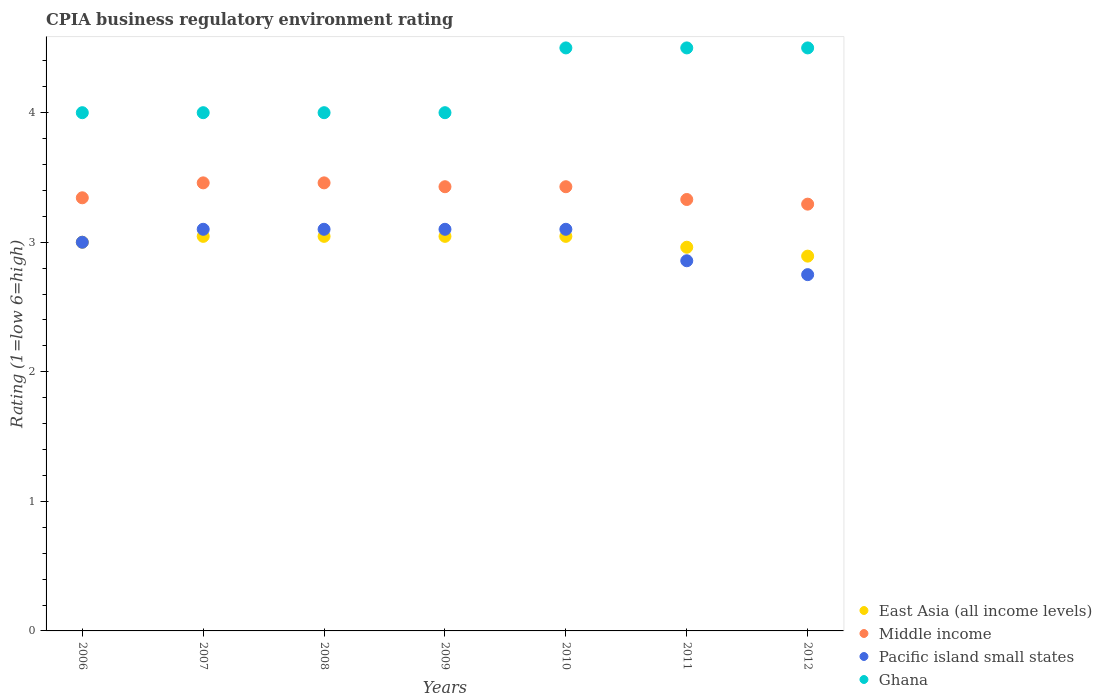How many different coloured dotlines are there?
Ensure brevity in your answer.  4. What is the CPIA rating in Middle income in 2009?
Provide a succinct answer. 3.43. Across all years, what is the maximum CPIA rating in Middle income?
Your answer should be very brief. 3.46. Across all years, what is the minimum CPIA rating in Pacific island small states?
Your response must be concise. 2.75. In which year was the CPIA rating in Ghana maximum?
Offer a very short reply. 2010. What is the total CPIA rating in East Asia (all income levels) in the graph?
Offer a terse response. 21.04. What is the difference between the CPIA rating in East Asia (all income levels) in 2008 and that in 2011?
Make the answer very short. 0.08. What is the difference between the CPIA rating in Ghana in 2006 and the CPIA rating in East Asia (all income levels) in 2007?
Keep it short and to the point. 0.95. What is the average CPIA rating in East Asia (all income levels) per year?
Ensure brevity in your answer.  3.01. In the year 2008, what is the difference between the CPIA rating in Ghana and CPIA rating in Pacific island small states?
Give a very brief answer. 0.9. What is the ratio of the CPIA rating in East Asia (all income levels) in 2007 to that in 2011?
Your answer should be compact. 1.03. Is the CPIA rating in Ghana in 2010 less than that in 2012?
Provide a short and direct response. No. What is the difference between the highest and the second highest CPIA rating in Ghana?
Provide a succinct answer. 0. What is the difference between the highest and the lowest CPIA rating in Ghana?
Keep it short and to the point. 0.5. Is it the case that in every year, the sum of the CPIA rating in East Asia (all income levels) and CPIA rating in Middle income  is greater than the sum of CPIA rating in Ghana and CPIA rating in Pacific island small states?
Your answer should be very brief. No. Is it the case that in every year, the sum of the CPIA rating in Ghana and CPIA rating in Middle income  is greater than the CPIA rating in East Asia (all income levels)?
Your response must be concise. Yes. Does the CPIA rating in Pacific island small states monotonically increase over the years?
Ensure brevity in your answer.  No. Is the CPIA rating in Ghana strictly greater than the CPIA rating in Pacific island small states over the years?
Offer a very short reply. Yes. Is the CPIA rating in East Asia (all income levels) strictly less than the CPIA rating in Ghana over the years?
Ensure brevity in your answer.  Yes. Does the graph contain any zero values?
Provide a short and direct response. No. Does the graph contain grids?
Your answer should be very brief. No. Where does the legend appear in the graph?
Your answer should be very brief. Bottom right. How many legend labels are there?
Provide a short and direct response. 4. What is the title of the graph?
Keep it short and to the point. CPIA business regulatory environment rating. What is the label or title of the X-axis?
Your response must be concise. Years. What is the Rating (1=low 6=high) in Middle income in 2006?
Your answer should be very brief. 3.34. What is the Rating (1=low 6=high) of Ghana in 2006?
Provide a succinct answer. 4. What is the Rating (1=low 6=high) in East Asia (all income levels) in 2007?
Keep it short and to the point. 3.05. What is the Rating (1=low 6=high) in Middle income in 2007?
Give a very brief answer. 3.46. What is the Rating (1=low 6=high) in Pacific island small states in 2007?
Offer a very short reply. 3.1. What is the Rating (1=low 6=high) in Ghana in 2007?
Give a very brief answer. 4. What is the Rating (1=low 6=high) in East Asia (all income levels) in 2008?
Offer a very short reply. 3.05. What is the Rating (1=low 6=high) in Middle income in 2008?
Provide a succinct answer. 3.46. What is the Rating (1=low 6=high) of Ghana in 2008?
Your answer should be very brief. 4. What is the Rating (1=low 6=high) of East Asia (all income levels) in 2009?
Your response must be concise. 3.05. What is the Rating (1=low 6=high) in Middle income in 2009?
Give a very brief answer. 3.43. What is the Rating (1=low 6=high) in Pacific island small states in 2009?
Make the answer very short. 3.1. What is the Rating (1=low 6=high) in East Asia (all income levels) in 2010?
Provide a succinct answer. 3.05. What is the Rating (1=low 6=high) in Middle income in 2010?
Your answer should be very brief. 3.43. What is the Rating (1=low 6=high) of Ghana in 2010?
Your answer should be very brief. 4.5. What is the Rating (1=low 6=high) of East Asia (all income levels) in 2011?
Provide a short and direct response. 2.96. What is the Rating (1=low 6=high) of Middle income in 2011?
Your answer should be very brief. 3.33. What is the Rating (1=low 6=high) of Pacific island small states in 2011?
Give a very brief answer. 2.86. What is the Rating (1=low 6=high) in Ghana in 2011?
Your answer should be very brief. 4.5. What is the Rating (1=low 6=high) in East Asia (all income levels) in 2012?
Ensure brevity in your answer.  2.89. What is the Rating (1=low 6=high) in Middle income in 2012?
Keep it short and to the point. 3.29. What is the Rating (1=low 6=high) in Pacific island small states in 2012?
Offer a terse response. 2.75. Across all years, what is the maximum Rating (1=low 6=high) in East Asia (all income levels)?
Your answer should be compact. 3.05. Across all years, what is the maximum Rating (1=low 6=high) in Middle income?
Provide a succinct answer. 3.46. Across all years, what is the minimum Rating (1=low 6=high) in East Asia (all income levels)?
Your answer should be very brief. 2.89. Across all years, what is the minimum Rating (1=low 6=high) in Middle income?
Offer a terse response. 3.29. Across all years, what is the minimum Rating (1=low 6=high) of Pacific island small states?
Provide a short and direct response. 2.75. What is the total Rating (1=low 6=high) in East Asia (all income levels) in the graph?
Your answer should be compact. 21.04. What is the total Rating (1=low 6=high) of Middle income in the graph?
Keep it short and to the point. 23.74. What is the total Rating (1=low 6=high) of Pacific island small states in the graph?
Offer a very short reply. 21.01. What is the total Rating (1=low 6=high) in Ghana in the graph?
Provide a short and direct response. 29.5. What is the difference between the Rating (1=low 6=high) in East Asia (all income levels) in 2006 and that in 2007?
Provide a short and direct response. -0.05. What is the difference between the Rating (1=low 6=high) of Middle income in 2006 and that in 2007?
Ensure brevity in your answer.  -0.12. What is the difference between the Rating (1=low 6=high) of East Asia (all income levels) in 2006 and that in 2008?
Offer a very short reply. -0.05. What is the difference between the Rating (1=low 6=high) in Middle income in 2006 and that in 2008?
Make the answer very short. -0.12. What is the difference between the Rating (1=low 6=high) in East Asia (all income levels) in 2006 and that in 2009?
Offer a very short reply. -0.05. What is the difference between the Rating (1=low 6=high) of Middle income in 2006 and that in 2009?
Your answer should be very brief. -0.09. What is the difference between the Rating (1=low 6=high) in East Asia (all income levels) in 2006 and that in 2010?
Your answer should be compact. -0.05. What is the difference between the Rating (1=low 6=high) in Middle income in 2006 and that in 2010?
Your answer should be very brief. -0.09. What is the difference between the Rating (1=low 6=high) in Ghana in 2006 and that in 2010?
Give a very brief answer. -0.5. What is the difference between the Rating (1=low 6=high) of East Asia (all income levels) in 2006 and that in 2011?
Make the answer very short. 0.04. What is the difference between the Rating (1=low 6=high) in Middle income in 2006 and that in 2011?
Provide a short and direct response. 0.01. What is the difference between the Rating (1=low 6=high) of Pacific island small states in 2006 and that in 2011?
Provide a succinct answer. 0.14. What is the difference between the Rating (1=low 6=high) in East Asia (all income levels) in 2006 and that in 2012?
Your answer should be very brief. 0.11. What is the difference between the Rating (1=low 6=high) in Middle income in 2006 and that in 2012?
Your answer should be compact. 0.05. What is the difference between the Rating (1=low 6=high) of Ghana in 2006 and that in 2012?
Give a very brief answer. -0.5. What is the difference between the Rating (1=low 6=high) of Middle income in 2007 and that in 2008?
Offer a very short reply. 0. What is the difference between the Rating (1=low 6=high) in Ghana in 2007 and that in 2008?
Your response must be concise. 0. What is the difference between the Rating (1=low 6=high) in East Asia (all income levels) in 2007 and that in 2009?
Provide a succinct answer. 0. What is the difference between the Rating (1=low 6=high) in Middle income in 2007 and that in 2009?
Provide a short and direct response. 0.03. What is the difference between the Rating (1=low 6=high) of Pacific island small states in 2007 and that in 2009?
Ensure brevity in your answer.  0. What is the difference between the Rating (1=low 6=high) of Ghana in 2007 and that in 2009?
Your answer should be very brief. 0. What is the difference between the Rating (1=low 6=high) in Middle income in 2007 and that in 2010?
Give a very brief answer. 0.03. What is the difference between the Rating (1=low 6=high) of Ghana in 2007 and that in 2010?
Your response must be concise. -0.5. What is the difference between the Rating (1=low 6=high) of East Asia (all income levels) in 2007 and that in 2011?
Make the answer very short. 0.08. What is the difference between the Rating (1=low 6=high) in Middle income in 2007 and that in 2011?
Offer a very short reply. 0.13. What is the difference between the Rating (1=low 6=high) of Pacific island small states in 2007 and that in 2011?
Keep it short and to the point. 0.24. What is the difference between the Rating (1=low 6=high) of East Asia (all income levels) in 2007 and that in 2012?
Keep it short and to the point. 0.15. What is the difference between the Rating (1=low 6=high) in Middle income in 2007 and that in 2012?
Your response must be concise. 0.16. What is the difference between the Rating (1=low 6=high) in Ghana in 2007 and that in 2012?
Ensure brevity in your answer.  -0.5. What is the difference between the Rating (1=low 6=high) of Middle income in 2008 and that in 2009?
Ensure brevity in your answer.  0.03. What is the difference between the Rating (1=low 6=high) of Pacific island small states in 2008 and that in 2009?
Your response must be concise. 0. What is the difference between the Rating (1=low 6=high) in Ghana in 2008 and that in 2009?
Give a very brief answer. 0. What is the difference between the Rating (1=low 6=high) in Middle income in 2008 and that in 2010?
Make the answer very short. 0.03. What is the difference between the Rating (1=low 6=high) in Pacific island small states in 2008 and that in 2010?
Ensure brevity in your answer.  0. What is the difference between the Rating (1=low 6=high) of East Asia (all income levels) in 2008 and that in 2011?
Your response must be concise. 0.08. What is the difference between the Rating (1=low 6=high) of Middle income in 2008 and that in 2011?
Keep it short and to the point. 0.13. What is the difference between the Rating (1=low 6=high) in Pacific island small states in 2008 and that in 2011?
Offer a terse response. 0.24. What is the difference between the Rating (1=low 6=high) in East Asia (all income levels) in 2008 and that in 2012?
Ensure brevity in your answer.  0.15. What is the difference between the Rating (1=low 6=high) in Middle income in 2008 and that in 2012?
Ensure brevity in your answer.  0.16. What is the difference between the Rating (1=low 6=high) in East Asia (all income levels) in 2009 and that in 2010?
Your response must be concise. 0. What is the difference between the Rating (1=low 6=high) in Ghana in 2009 and that in 2010?
Keep it short and to the point. -0.5. What is the difference between the Rating (1=low 6=high) in East Asia (all income levels) in 2009 and that in 2011?
Provide a short and direct response. 0.08. What is the difference between the Rating (1=low 6=high) in Middle income in 2009 and that in 2011?
Your answer should be compact. 0.1. What is the difference between the Rating (1=low 6=high) of Pacific island small states in 2009 and that in 2011?
Provide a succinct answer. 0.24. What is the difference between the Rating (1=low 6=high) of East Asia (all income levels) in 2009 and that in 2012?
Keep it short and to the point. 0.15. What is the difference between the Rating (1=low 6=high) of Middle income in 2009 and that in 2012?
Your response must be concise. 0.13. What is the difference between the Rating (1=low 6=high) in East Asia (all income levels) in 2010 and that in 2011?
Make the answer very short. 0.08. What is the difference between the Rating (1=low 6=high) in Middle income in 2010 and that in 2011?
Your answer should be very brief. 0.1. What is the difference between the Rating (1=low 6=high) in Pacific island small states in 2010 and that in 2011?
Provide a short and direct response. 0.24. What is the difference between the Rating (1=low 6=high) of East Asia (all income levels) in 2010 and that in 2012?
Provide a short and direct response. 0.15. What is the difference between the Rating (1=low 6=high) in Middle income in 2010 and that in 2012?
Offer a very short reply. 0.13. What is the difference between the Rating (1=low 6=high) in Ghana in 2010 and that in 2012?
Provide a succinct answer. 0. What is the difference between the Rating (1=low 6=high) in East Asia (all income levels) in 2011 and that in 2012?
Give a very brief answer. 0.07. What is the difference between the Rating (1=low 6=high) in Middle income in 2011 and that in 2012?
Offer a terse response. 0.04. What is the difference between the Rating (1=low 6=high) of Pacific island small states in 2011 and that in 2012?
Your answer should be compact. 0.11. What is the difference between the Rating (1=low 6=high) in Ghana in 2011 and that in 2012?
Offer a terse response. 0. What is the difference between the Rating (1=low 6=high) in East Asia (all income levels) in 2006 and the Rating (1=low 6=high) in Middle income in 2007?
Offer a very short reply. -0.46. What is the difference between the Rating (1=low 6=high) of Middle income in 2006 and the Rating (1=low 6=high) of Pacific island small states in 2007?
Offer a terse response. 0.24. What is the difference between the Rating (1=low 6=high) of Middle income in 2006 and the Rating (1=low 6=high) of Ghana in 2007?
Offer a terse response. -0.66. What is the difference between the Rating (1=low 6=high) of Pacific island small states in 2006 and the Rating (1=low 6=high) of Ghana in 2007?
Your response must be concise. -1. What is the difference between the Rating (1=low 6=high) in East Asia (all income levels) in 2006 and the Rating (1=low 6=high) in Middle income in 2008?
Make the answer very short. -0.46. What is the difference between the Rating (1=low 6=high) of East Asia (all income levels) in 2006 and the Rating (1=low 6=high) of Ghana in 2008?
Give a very brief answer. -1. What is the difference between the Rating (1=low 6=high) in Middle income in 2006 and the Rating (1=low 6=high) in Pacific island small states in 2008?
Provide a short and direct response. 0.24. What is the difference between the Rating (1=low 6=high) in Middle income in 2006 and the Rating (1=low 6=high) in Ghana in 2008?
Make the answer very short. -0.66. What is the difference between the Rating (1=low 6=high) in Pacific island small states in 2006 and the Rating (1=low 6=high) in Ghana in 2008?
Provide a short and direct response. -1. What is the difference between the Rating (1=low 6=high) in East Asia (all income levels) in 2006 and the Rating (1=low 6=high) in Middle income in 2009?
Give a very brief answer. -0.43. What is the difference between the Rating (1=low 6=high) in East Asia (all income levels) in 2006 and the Rating (1=low 6=high) in Pacific island small states in 2009?
Offer a terse response. -0.1. What is the difference between the Rating (1=low 6=high) in Middle income in 2006 and the Rating (1=low 6=high) in Pacific island small states in 2009?
Make the answer very short. 0.24. What is the difference between the Rating (1=low 6=high) in Middle income in 2006 and the Rating (1=low 6=high) in Ghana in 2009?
Make the answer very short. -0.66. What is the difference between the Rating (1=low 6=high) in Pacific island small states in 2006 and the Rating (1=low 6=high) in Ghana in 2009?
Give a very brief answer. -1. What is the difference between the Rating (1=low 6=high) of East Asia (all income levels) in 2006 and the Rating (1=low 6=high) of Middle income in 2010?
Your response must be concise. -0.43. What is the difference between the Rating (1=low 6=high) of Middle income in 2006 and the Rating (1=low 6=high) of Pacific island small states in 2010?
Your answer should be very brief. 0.24. What is the difference between the Rating (1=low 6=high) in Middle income in 2006 and the Rating (1=low 6=high) in Ghana in 2010?
Your answer should be very brief. -1.16. What is the difference between the Rating (1=low 6=high) in Pacific island small states in 2006 and the Rating (1=low 6=high) in Ghana in 2010?
Provide a succinct answer. -1.5. What is the difference between the Rating (1=low 6=high) in East Asia (all income levels) in 2006 and the Rating (1=low 6=high) in Middle income in 2011?
Give a very brief answer. -0.33. What is the difference between the Rating (1=low 6=high) in East Asia (all income levels) in 2006 and the Rating (1=low 6=high) in Pacific island small states in 2011?
Offer a very short reply. 0.14. What is the difference between the Rating (1=low 6=high) of East Asia (all income levels) in 2006 and the Rating (1=low 6=high) of Ghana in 2011?
Provide a short and direct response. -1.5. What is the difference between the Rating (1=low 6=high) of Middle income in 2006 and the Rating (1=low 6=high) of Pacific island small states in 2011?
Provide a succinct answer. 0.49. What is the difference between the Rating (1=low 6=high) of Middle income in 2006 and the Rating (1=low 6=high) of Ghana in 2011?
Give a very brief answer. -1.16. What is the difference between the Rating (1=low 6=high) in East Asia (all income levels) in 2006 and the Rating (1=low 6=high) in Middle income in 2012?
Your response must be concise. -0.29. What is the difference between the Rating (1=low 6=high) of East Asia (all income levels) in 2006 and the Rating (1=low 6=high) of Pacific island small states in 2012?
Your answer should be compact. 0.25. What is the difference between the Rating (1=low 6=high) of Middle income in 2006 and the Rating (1=low 6=high) of Pacific island small states in 2012?
Keep it short and to the point. 0.59. What is the difference between the Rating (1=low 6=high) in Middle income in 2006 and the Rating (1=low 6=high) in Ghana in 2012?
Offer a very short reply. -1.16. What is the difference between the Rating (1=low 6=high) in Pacific island small states in 2006 and the Rating (1=low 6=high) in Ghana in 2012?
Your answer should be very brief. -1.5. What is the difference between the Rating (1=low 6=high) in East Asia (all income levels) in 2007 and the Rating (1=low 6=high) in Middle income in 2008?
Keep it short and to the point. -0.41. What is the difference between the Rating (1=low 6=high) in East Asia (all income levels) in 2007 and the Rating (1=low 6=high) in Pacific island small states in 2008?
Your answer should be compact. -0.05. What is the difference between the Rating (1=low 6=high) of East Asia (all income levels) in 2007 and the Rating (1=low 6=high) of Ghana in 2008?
Your answer should be compact. -0.95. What is the difference between the Rating (1=low 6=high) in Middle income in 2007 and the Rating (1=low 6=high) in Pacific island small states in 2008?
Provide a short and direct response. 0.36. What is the difference between the Rating (1=low 6=high) of Middle income in 2007 and the Rating (1=low 6=high) of Ghana in 2008?
Offer a terse response. -0.54. What is the difference between the Rating (1=low 6=high) of East Asia (all income levels) in 2007 and the Rating (1=low 6=high) of Middle income in 2009?
Keep it short and to the point. -0.38. What is the difference between the Rating (1=low 6=high) of East Asia (all income levels) in 2007 and the Rating (1=low 6=high) of Pacific island small states in 2009?
Ensure brevity in your answer.  -0.05. What is the difference between the Rating (1=low 6=high) of East Asia (all income levels) in 2007 and the Rating (1=low 6=high) of Ghana in 2009?
Keep it short and to the point. -0.95. What is the difference between the Rating (1=low 6=high) of Middle income in 2007 and the Rating (1=low 6=high) of Pacific island small states in 2009?
Offer a terse response. 0.36. What is the difference between the Rating (1=low 6=high) of Middle income in 2007 and the Rating (1=low 6=high) of Ghana in 2009?
Your answer should be compact. -0.54. What is the difference between the Rating (1=low 6=high) of East Asia (all income levels) in 2007 and the Rating (1=low 6=high) of Middle income in 2010?
Your answer should be very brief. -0.38. What is the difference between the Rating (1=low 6=high) of East Asia (all income levels) in 2007 and the Rating (1=low 6=high) of Pacific island small states in 2010?
Provide a short and direct response. -0.05. What is the difference between the Rating (1=low 6=high) in East Asia (all income levels) in 2007 and the Rating (1=low 6=high) in Ghana in 2010?
Keep it short and to the point. -1.45. What is the difference between the Rating (1=low 6=high) in Middle income in 2007 and the Rating (1=low 6=high) in Pacific island small states in 2010?
Your response must be concise. 0.36. What is the difference between the Rating (1=low 6=high) in Middle income in 2007 and the Rating (1=low 6=high) in Ghana in 2010?
Your response must be concise. -1.04. What is the difference between the Rating (1=low 6=high) in East Asia (all income levels) in 2007 and the Rating (1=low 6=high) in Middle income in 2011?
Give a very brief answer. -0.28. What is the difference between the Rating (1=low 6=high) in East Asia (all income levels) in 2007 and the Rating (1=low 6=high) in Pacific island small states in 2011?
Keep it short and to the point. 0.19. What is the difference between the Rating (1=low 6=high) of East Asia (all income levels) in 2007 and the Rating (1=low 6=high) of Ghana in 2011?
Provide a short and direct response. -1.45. What is the difference between the Rating (1=low 6=high) of Middle income in 2007 and the Rating (1=low 6=high) of Pacific island small states in 2011?
Give a very brief answer. 0.6. What is the difference between the Rating (1=low 6=high) of Middle income in 2007 and the Rating (1=low 6=high) of Ghana in 2011?
Your answer should be compact. -1.04. What is the difference between the Rating (1=low 6=high) in East Asia (all income levels) in 2007 and the Rating (1=low 6=high) in Middle income in 2012?
Keep it short and to the point. -0.25. What is the difference between the Rating (1=low 6=high) of East Asia (all income levels) in 2007 and the Rating (1=low 6=high) of Pacific island small states in 2012?
Your response must be concise. 0.3. What is the difference between the Rating (1=low 6=high) of East Asia (all income levels) in 2007 and the Rating (1=low 6=high) of Ghana in 2012?
Keep it short and to the point. -1.45. What is the difference between the Rating (1=low 6=high) of Middle income in 2007 and the Rating (1=low 6=high) of Pacific island small states in 2012?
Your answer should be very brief. 0.71. What is the difference between the Rating (1=low 6=high) in Middle income in 2007 and the Rating (1=low 6=high) in Ghana in 2012?
Offer a terse response. -1.04. What is the difference between the Rating (1=low 6=high) of Pacific island small states in 2007 and the Rating (1=low 6=high) of Ghana in 2012?
Your answer should be very brief. -1.4. What is the difference between the Rating (1=low 6=high) of East Asia (all income levels) in 2008 and the Rating (1=low 6=high) of Middle income in 2009?
Make the answer very short. -0.38. What is the difference between the Rating (1=low 6=high) of East Asia (all income levels) in 2008 and the Rating (1=low 6=high) of Pacific island small states in 2009?
Make the answer very short. -0.05. What is the difference between the Rating (1=low 6=high) in East Asia (all income levels) in 2008 and the Rating (1=low 6=high) in Ghana in 2009?
Make the answer very short. -0.95. What is the difference between the Rating (1=low 6=high) of Middle income in 2008 and the Rating (1=low 6=high) of Pacific island small states in 2009?
Offer a terse response. 0.36. What is the difference between the Rating (1=low 6=high) in Middle income in 2008 and the Rating (1=low 6=high) in Ghana in 2009?
Ensure brevity in your answer.  -0.54. What is the difference between the Rating (1=low 6=high) of East Asia (all income levels) in 2008 and the Rating (1=low 6=high) of Middle income in 2010?
Make the answer very short. -0.38. What is the difference between the Rating (1=low 6=high) of East Asia (all income levels) in 2008 and the Rating (1=low 6=high) of Pacific island small states in 2010?
Your answer should be compact. -0.05. What is the difference between the Rating (1=low 6=high) in East Asia (all income levels) in 2008 and the Rating (1=low 6=high) in Ghana in 2010?
Your answer should be compact. -1.45. What is the difference between the Rating (1=low 6=high) of Middle income in 2008 and the Rating (1=low 6=high) of Pacific island small states in 2010?
Your answer should be very brief. 0.36. What is the difference between the Rating (1=low 6=high) of Middle income in 2008 and the Rating (1=low 6=high) of Ghana in 2010?
Offer a terse response. -1.04. What is the difference between the Rating (1=low 6=high) in Pacific island small states in 2008 and the Rating (1=low 6=high) in Ghana in 2010?
Make the answer very short. -1.4. What is the difference between the Rating (1=low 6=high) of East Asia (all income levels) in 2008 and the Rating (1=low 6=high) of Middle income in 2011?
Keep it short and to the point. -0.28. What is the difference between the Rating (1=low 6=high) of East Asia (all income levels) in 2008 and the Rating (1=low 6=high) of Pacific island small states in 2011?
Offer a very short reply. 0.19. What is the difference between the Rating (1=low 6=high) in East Asia (all income levels) in 2008 and the Rating (1=low 6=high) in Ghana in 2011?
Offer a terse response. -1.45. What is the difference between the Rating (1=low 6=high) in Middle income in 2008 and the Rating (1=low 6=high) in Pacific island small states in 2011?
Give a very brief answer. 0.6. What is the difference between the Rating (1=low 6=high) of Middle income in 2008 and the Rating (1=low 6=high) of Ghana in 2011?
Provide a short and direct response. -1.04. What is the difference between the Rating (1=low 6=high) of East Asia (all income levels) in 2008 and the Rating (1=low 6=high) of Middle income in 2012?
Make the answer very short. -0.25. What is the difference between the Rating (1=low 6=high) of East Asia (all income levels) in 2008 and the Rating (1=low 6=high) of Pacific island small states in 2012?
Offer a very short reply. 0.3. What is the difference between the Rating (1=low 6=high) in East Asia (all income levels) in 2008 and the Rating (1=low 6=high) in Ghana in 2012?
Provide a short and direct response. -1.45. What is the difference between the Rating (1=low 6=high) of Middle income in 2008 and the Rating (1=low 6=high) of Pacific island small states in 2012?
Keep it short and to the point. 0.71. What is the difference between the Rating (1=low 6=high) in Middle income in 2008 and the Rating (1=low 6=high) in Ghana in 2012?
Give a very brief answer. -1.04. What is the difference between the Rating (1=low 6=high) in Pacific island small states in 2008 and the Rating (1=low 6=high) in Ghana in 2012?
Ensure brevity in your answer.  -1.4. What is the difference between the Rating (1=low 6=high) of East Asia (all income levels) in 2009 and the Rating (1=low 6=high) of Middle income in 2010?
Your response must be concise. -0.38. What is the difference between the Rating (1=low 6=high) of East Asia (all income levels) in 2009 and the Rating (1=low 6=high) of Pacific island small states in 2010?
Make the answer very short. -0.05. What is the difference between the Rating (1=low 6=high) of East Asia (all income levels) in 2009 and the Rating (1=low 6=high) of Ghana in 2010?
Your response must be concise. -1.45. What is the difference between the Rating (1=low 6=high) of Middle income in 2009 and the Rating (1=low 6=high) of Pacific island small states in 2010?
Provide a succinct answer. 0.33. What is the difference between the Rating (1=low 6=high) in Middle income in 2009 and the Rating (1=low 6=high) in Ghana in 2010?
Your response must be concise. -1.07. What is the difference between the Rating (1=low 6=high) in East Asia (all income levels) in 2009 and the Rating (1=low 6=high) in Middle income in 2011?
Provide a short and direct response. -0.28. What is the difference between the Rating (1=low 6=high) of East Asia (all income levels) in 2009 and the Rating (1=low 6=high) of Pacific island small states in 2011?
Give a very brief answer. 0.19. What is the difference between the Rating (1=low 6=high) in East Asia (all income levels) in 2009 and the Rating (1=low 6=high) in Ghana in 2011?
Offer a terse response. -1.45. What is the difference between the Rating (1=low 6=high) of Middle income in 2009 and the Rating (1=low 6=high) of Pacific island small states in 2011?
Offer a terse response. 0.57. What is the difference between the Rating (1=low 6=high) of Middle income in 2009 and the Rating (1=low 6=high) of Ghana in 2011?
Make the answer very short. -1.07. What is the difference between the Rating (1=low 6=high) of East Asia (all income levels) in 2009 and the Rating (1=low 6=high) of Middle income in 2012?
Provide a succinct answer. -0.25. What is the difference between the Rating (1=low 6=high) of East Asia (all income levels) in 2009 and the Rating (1=low 6=high) of Pacific island small states in 2012?
Provide a short and direct response. 0.3. What is the difference between the Rating (1=low 6=high) of East Asia (all income levels) in 2009 and the Rating (1=low 6=high) of Ghana in 2012?
Give a very brief answer. -1.45. What is the difference between the Rating (1=low 6=high) in Middle income in 2009 and the Rating (1=low 6=high) in Pacific island small states in 2012?
Provide a short and direct response. 0.68. What is the difference between the Rating (1=low 6=high) of Middle income in 2009 and the Rating (1=low 6=high) of Ghana in 2012?
Keep it short and to the point. -1.07. What is the difference between the Rating (1=low 6=high) of Pacific island small states in 2009 and the Rating (1=low 6=high) of Ghana in 2012?
Your response must be concise. -1.4. What is the difference between the Rating (1=low 6=high) in East Asia (all income levels) in 2010 and the Rating (1=low 6=high) in Middle income in 2011?
Your answer should be very brief. -0.28. What is the difference between the Rating (1=low 6=high) in East Asia (all income levels) in 2010 and the Rating (1=low 6=high) in Pacific island small states in 2011?
Offer a very short reply. 0.19. What is the difference between the Rating (1=low 6=high) of East Asia (all income levels) in 2010 and the Rating (1=low 6=high) of Ghana in 2011?
Make the answer very short. -1.45. What is the difference between the Rating (1=low 6=high) in Middle income in 2010 and the Rating (1=low 6=high) in Ghana in 2011?
Your answer should be very brief. -1.07. What is the difference between the Rating (1=low 6=high) of Pacific island small states in 2010 and the Rating (1=low 6=high) of Ghana in 2011?
Offer a terse response. -1.4. What is the difference between the Rating (1=low 6=high) in East Asia (all income levels) in 2010 and the Rating (1=low 6=high) in Middle income in 2012?
Offer a terse response. -0.25. What is the difference between the Rating (1=low 6=high) in East Asia (all income levels) in 2010 and the Rating (1=low 6=high) in Pacific island small states in 2012?
Your response must be concise. 0.3. What is the difference between the Rating (1=low 6=high) of East Asia (all income levels) in 2010 and the Rating (1=low 6=high) of Ghana in 2012?
Your answer should be compact. -1.45. What is the difference between the Rating (1=low 6=high) of Middle income in 2010 and the Rating (1=low 6=high) of Pacific island small states in 2012?
Provide a short and direct response. 0.68. What is the difference between the Rating (1=low 6=high) in Middle income in 2010 and the Rating (1=low 6=high) in Ghana in 2012?
Offer a terse response. -1.07. What is the difference between the Rating (1=low 6=high) in East Asia (all income levels) in 2011 and the Rating (1=low 6=high) in Middle income in 2012?
Your answer should be compact. -0.33. What is the difference between the Rating (1=low 6=high) in East Asia (all income levels) in 2011 and the Rating (1=low 6=high) in Pacific island small states in 2012?
Offer a terse response. 0.21. What is the difference between the Rating (1=low 6=high) in East Asia (all income levels) in 2011 and the Rating (1=low 6=high) in Ghana in 2012?
Provide a short and direct response. -1.54. What is the difference between the Rating (1=low 6=high) of Middle income in 2011 and the Rating (1=low 6=high) of Pacific island small states in 2012?
Keep it short and to the point. 0.58. What is the difference between the Rating (1=low 6=high) of Middle income in 2011 and the Rating (1=low 6=high) of Ghana in 2012?
Provide a short and direct response. -1.17. What is the difference between the Rating (1=low 6=high) of Pacific island small states in 2011 and the Rating (1=low 6=high) of Ghana in 2012?
Your answer should be compact. -1.64. What is the average Rating (1=low 6=high) in East Asia (all income levels) per year?
Your answer should be compact. 3.01. What is the average Rating (1=low 6=high) of Middle income per year?
Keep it short and to the point. 3.39. What is the average Rating (1=low 6=high) of Pacific island small states per year?
Your answer should be very brief. 3. What is the average Rating (1=low 6=high) in Ghana per year?
Provide a short and direct response. 4.21. In the year 2006, what is the difference between the Rating (1=low 6=high) in East Asia (all income levels) and Rating (1=low 6=high) in Middle income?
Your answer should be very brief. -0.34. In the year 2006, what is the difference between the Rating (1=low 6=high) in East Asia (all income levels) and Rating (1=low 6=high) in Pacific island small states?
Offer a very short reply. 0. In the year 2006, what is the difference between the Rating (1=low 6=high) of East Asia (all income levels) and Rating (1=low 6=high) of Ghana?
Keep it short and to the point. -1. In the year 2006, what is the difference between the Rating (1=low 6=high) of Middle income and Rating (1=low 6=high) of Pacific island small states?
Keep it short and to the point. 0.34. In the year 2006, what is the difference between the Rating (1=low 6=high) in Middle income and Rating (1=low 6=high) in Ghana?
Provide a short and direct response. -0.66. In the year 2006, what is the difference between the Rating (1=low 6=high) of Pacific island small states and Rating (1=low 6=high) of Ghana?
Provide a short and direct response. -1. In the year 2007, what is the difference between the Rating (1=low 6=high) of East Asia (all income levels) and Rating (1=low 6=high) of Middle income?
Keep it short and to the point. -0.41. In the year 2007, what is the difference between the Rating (1=low 6=high) in East Asia (all income levels) and Rating (1=low 6=high) in Pacific island small states?
Give a very brief answer. -0.05. In the year 2007, what is the difference between the Rating (1=low 6=high) of East Asia (all income levels) and Rating (1=low 6=high) of Ghana?
Give a very brief answer. -0.95. In the year 2007, what is the difference between the Rating (1=low 6=high) in Middle income and Rating (1=low 6=high) in Pacific island small states?
Your response must be concise. 0.36. In the year 2007, what is the difference between the Rating (1=low 6=high) of Middle income and Rating (1=low 6=high) of Ghana?
Provide a succinct answer. -0.54. In the year 2007, what is the difference between the Rating (1=low 6=high) of Pacific island small states and Rating (1=low 6=high) of Ghana?
Your response must be concise. -0.9. In the year 2008, what is the difference between the Rating (1=low 6=high) in East Asia (all income levels) and Rating (1=low 6=high) in Middle income?
Provide a short and direct response. -0.41. In the year 2008, what is the difference between the Rating (1=low 6=high) of East Asia (all income levels) and Rating (1=low 6=high) of Pacific island small states?
Keep it short and to the point. -0.05. In the year 2008, what is the difference between the Rating (1=low 6=high) of East Asia (all income levels) and Rating (1=low 6=high) of Ghana?
Your response must be concise. -0.95. In the year 2008, what is the difference between the Rating (1=low 6=high) of Middle income and Rating (1=low 6=high) of Pacific island small states?
Ensure brevity in your answer.  0.36. In the year 2008, what is the difference between the Rating (1=low 6=high) in Middle income and Rating (1=low 6=high) in Ghana?
Provide a succinct answer. -0.54. In the year 2009, what is the difference between the Rating (1=low 6=high) in East Asia (all income levels) and Rating (1=low 6=high) in Middle income?
Offer a terse response. -0.38. In the year 2009, what is the difference between the Rating (1=low 6=high) of East Asia (all income levels) and Rating (1=low 6=high) of Pacific island small states?
Offer a very short reply. -0.05. In the year 2009, what is the difference between the Rating (1=low 6=high) in East Asia (all income levels) and Rating (1=low 6=high) in Ghana?
Offer a terse response. -0.95. In the year 2009, what is the difference between the Rating (1=low 6=high) in Middle income and Rating (1=low 6=high) in Pacific island small states?
Make the answer very short. 0.33. In the year 2009, what is the difference between the Rating (1=low 6=high) of Middle income and Rating (1=low 6=high) of Ghana?
Keep it short and to the point. -0.57. In the year 2010, what is the difference between the Rating (1=low 6=high) of East Asia (all income levels) and Rating (1=low 6=high) of Middle income?
Ensure brevity in your answer.  -0.38. In the year 2010, what is the difference between the Rating (1=low 6=high) of East Asia (all income levels) and Rating (1=low 6=high) of Pacific island small states?
Offer a very short reply. -0.05. In the year 2010, what is the difference between the Rating (1=low 6=high) of East Asia (all income levels) and Rating (1=low 6=high) of Ghana?
Offer a very short reply. -1.45. In the year 2010, what is the difference between the Rating (1=low 6=high) in Middle income and Rating (1=low 6=high) in Pacific island small states?
Offer a terse response. 0.33. In the year 2010, what is the difference between the Rating (1=low 6=high) in Middle income and Rating (1=low 6=high) in Ghana?
Keep it short and to the point. -1.07. In the year 2011, what is the difference between the Rating (1=low 6=high) in East Asia (all income levels) and Rating (1=low 6=high) in Middle income?
Ensure brevity in your answer.  -0.37. In the year 2011, what is the difference between the Rating (1=low 6=high) in East Asia (all income levels) and Rating (1=low 6=high) in Pacific island small states?
Your answer should be very brief. 0.1. In the year 2011, what is the difference between the Rating (1=low 6=high) of East Asia (all income levels) and Rating (1=low 6=high) of Ghana?
Give a very brief answer. -1.54. In the year 2011, what is the difference between the Rating (1=low 6=high) in Middle income and Rating (1=low 6=high) in Pacific island small states?
Your answer should be compact. 0.47. In the year 2011, what is the difference between the Rating (1=low 6=high) in Middle income and Rating (1=low 6=high) in Ghana?
Your answer should be compact. -1.17. In the year 2011, what is the difference between the Rating (1=low 6=high) in Pacific island small states and Rating (1=low 6=high) in Ghana?
Your answer should be very brief. -1.64. In the year 2012, what is the difference between the Rating (1=low 6=high) in East Asia (all income levels) and Rating (1=low 6=high) in Middle income?
Your response must be concise. -0.4. In the year 2012, what is the difference between the Rating (1=low 6=high) of East Asia (all income levels) and Rating (1=low 6=high) of Pacific island small states?
Ensure brevity in your answer.  0.14. In the year 2012, what is the difference between the Rating (1=low 6=high) in East Asia (all income levels) and Rating (1=low 6=high) in Ghana?
Make the answer very short. -1.61. In the year 2012, what is the difference between the Rating (1=low 6=high) in Middle income and Rating (1=low 6=high) in Pacific island small states?
Provide a short and direct response. 0.54. In the year 2012, what is the difference between the Rating (1=low 6=high) of Middle income and Rating (1=low 6=high) of Ghana?
Offer a very short reply. -1.21. In the year 2012, what is the difference between the Rating (1=low 6=high) of Pacific island small states and Rating (1=low 6=high) of Ghana?
Your answer should be very brief. -1.75. What is the ratio of the Rating (1=low 6=high) of East Asia (all income levels) in 2006 to that in 2007?
Give a very brief answer. 0.99. What is the ratio of the Rating (1=low 6=high) of Middle income in 2006 to that in 2007?
Provide a succinct answer. 0.97. What is the ratio of the Rating (1=low 6=high) in Ghana in 2006 to that in 2007?
Keep it short and to the point. 1. What is the ratio of the Rating (1=low 6=high) of East Asia (all income levels) in 2006 to that in 2008?
Make the answer very short. 0.99. What is the ratio of the Rating (1=low 6=high) of Middle income in 2006 to that in 2008?
Make the answer very short. 0.97. What is the ratio of the Rating (1=low 6=high) in Ghana in 2006 to that in 2008?
Keep it short and to the point. 1. What is the ratio of the Rating (1=low 6=high) of East Asia (all income levels) in 2006 to that in 2009?
Offer a terse response. 0.99. What is the ratio of the Rating (1=low 6=high) in Middle income in 2006 to that in 2009?
Your answer should be compact. 0.98. What is the ratio of the Rating (1=low 6=high) of East Asia (all income levels) in 2006 to that in 2010?
Your answer should be compact. 0.99. What is the ratio of the Rating (1=low 6=high) of Middle income in 2006 to that in 2010?
Your answer should be compact. 0.98. What is the ratio of the Rating (1=low 6=high) in Middle income in 2006 to that in 2011?
Keep it short and to the point. 1. What is the ratio of the Rating (1=low 6=high) of Pacific island small states in 2006 to that in 2011?
Your answer should be very brief. 1.05. What is the ratio of the Rating (1=low 6=high) of Ghana in 2006 to that in 2011?
Provide a short and direct response. 0.89. What is the ratio of the Rating (1=low 6=high) in Middle income in 2006 to that in 2012?
Offer a terse response. 1.01. What is the ratio of the Rating (1=low 6=high) of Pacific island small states in 2006 to that in 2012?
Make the answer very short. 1.09. What is the ratio of the Rating (1=low 6=high) in East Asia (all income levels) in 2007 to that in 2008?
Provide a succinct answer. 1. What is the ratio of the Rating (1=low 6=high) of East Asia (all income levels) in 2007 to that in 2009?
Your answer should be very brief. 1. What is the ratio of the Rating (1=low 6=high) in Middle income in 2007 to that in 2009?
Offer a very short reply. 1.01. What is the ratio of the Rating (1=low 6=high) of Pacific island small states in 2007 to that in 2009?
Provide a short and direct response. 1. What is the ratio of the Rating (1=low 6=high) of Middle income in 2007 to that in 2010?
Give a very brief answer. 1.01. What is the ratio of the Rating (1=low 6=high) of Pacific island small states in 2007 to that in 2010?
Make the answer very short. 1. What is the ratio of the Rating (1=low 6=high) in Ghana in 2007 to that in 2010?
Offer a terse response. 0.89. What is the ratio of the Rating (1=low 6=high) of East Asia (all income levels) in 2007 to that in 2011?
Offer a terse response. 1.03. What is the ratio of the Rating (1=low 6=high) of Middle income in 2007 to that in 2011?
Give a very brief answer. 1.04. What is the ratio of the Rating (1=low 6=high) of Pacific island small states in 2007 to that in 2011?
Offer a very short reply. 1.08. What is the ratio of the Rating (1=low 6=high) in Ghana in 2007 to that in 2011?
Your response must be concise. 0.89. What is the ratio of the Rating (1=low 6=high) of East Asia (all income levels) in 2007 to that in 2012?
Give a very brief answer. 1.05. What is the ratio of the Rating (1=low 6=high) in Middle income in 2007 to that in 2012?
Your response must be concise. 1.05. What is the ratio of the Rating (1=low 6=high) of Pacific island small states in 2007 to that in 2012?
Your answer should be very brief. 1.13. What is the ratio of the Rating (1=low 6=high) in Middle income in 2008 to that in 2009?
Make the answer very short. 1.01. What is the ratio of the Rating (1=low 6=high) in Middle income in 2008 to that in 2010?
Keep it short and to the point. 1.01. What is the ratio of the Rating (1=low 6=high) of Pacific island small states in 2008 to that in 2010?
Make the answer very short. 1. What is the ratio of the Rating (1=low 6=high) in East Asia (all income levels) in 2008 to that in 2011?
Provide a short and direct response. 1.03. What is the ratio of the Rating (1=low 6=high) of Middle income in 2008 to that in 2011?
Ensure brevity in your answer.  1.04. What is the ratio of the Rating (1=low 6=high) in Pacific island small states in 2008 to that in 2011?
Provide a short and direct response. 1.08. What is the ratio of the Rating (1=low 6=high) of East Asia (all income levels) in 2008 to that in 2012?
Your answer should be very brief. 1.05. What is the ratio of the Rating (1=low 6=high) of Middle income in 2008 to that in 2012?
Offer a very short reply. 1.05. What is the ratio of the Rating (1=low 6=high) in Pacific island small states in 2008 to that in 2012?
Your response must be concise. 1.13. What is the ratio of the Rating (1=low 6=high) in Ghana in 2008 to that in 2012?
Ensure brevity in your answer.  0.89. What is the ratio of the Rating (1=low 6=high) of Middle income in 2009 to that in 2010?
Your answer should be very brief. 1. What is the ratio of the Rating (1=low 6=high) in Pacific island small states in 2009 to that in 2010?
Offer a very short reply. 1. What is the ratio of the Rating (1=low 6=high) in Ghana in 2009 to that in 2010?
Offer a very short reply. 0.89. What is the ratio of the Rating (1=low 6=high) of East Asia (all income levels) in 2009 to that in 2011?
Give a very brief answer. 1.03. What is the ratio of the Rating (1=low 6=high) of Middle income in 2009 to that in 2011?
Make the answer very short. 1.03. What is the ratio of the Rating (1=low 6=high) in Pacific island small states in 2009 to that in 2011?
Keep it short and to the point. 1.08. What is the ratio of the Rating (1=low 6=high) in East Asia (all income levels) in 2009 to that in 2012?
Your answer should be compact. 1.05. What is the ratio of the Rating (1=low 6=high) in Middle income in 2009 to that in 2012?
Make the answer very short. 1.04. What is the ratio of the Rating (1=low 6=high) in Pacific island small states in 2009 to that in 2012?
Provide a short and direct response. 1.13. What is the ratio of the Rating (1=low 6=high) of East Asia (all income levels) in 2010 to that in 2011?
Provide a short and direct response. 1.03. What is the ratio of the Rating (1=low 6=high) in Middle income in 2010 to that in 2011?
Make the answer very short. 1.03. What is the ratio of the Rating (1=low 6=high) in Pacific island small states in 2010 to that in 2011?
Offer a terse response. 1.08. What is the ratio of the Rating (1=low 6=high) of Ghana in 2010 to that in 2011?
Keep it short and to the point. 1. What is the ratio of the Rating (1=low 6=high) of East Asia (all income levels) in 2010 to that in 2012?
Give a very brief answer. 1.05. What is the ratio of the Rating (1=low 6=high) in Middle income in 2010 to that in 2012?
Give a very brief answer. 1.04. What is the ratio of the Rating (1=low 6=high) in Pacific island small states in 2010 to that in 2012?
Your answer should be compact. 1.13. What is the ratio of the Rating (1=low 6=high) in Ghana in 2010 to that in 2012?
Your answer should be very brief. 1. What is the ratio of the Rating (1=low 6=high) in East Asia (all income levels) in 2011 to that in 2012?
Provide a short and direct response. 1.02. What is the ratio of the Rating (1=low 6=high) of Middle income in 2011 to that in 2012?
Offer a terse response. 1.01. What is the ratio of the Rating (1=low 6=high) of Pacific island small states in 2011 to that in 2012?
Offer a terse response. 1.04. What is the ratio of the Rating (1=low 6=high) of Ghana in 2011 to that in 2012?
Make the answer very short. 1. What is the difference between the highest and the second highest Rating (1=low 6=high) in Ghana?
Provide a succinct answer. 0. What is the difference between the highest and the lowest Rating (1=low 6=high) of East Asia (all income levels)?
Your response must be concise. 0.15. What is the difference between the highest and the lowest Rating (1=low 6=high) of Middle income?
Your answer should be compact. 0.16. What is the difference between the highest and the lowest Rating (1=low 6=high) in Ghana?
Keep it short and to the point. 0.5. 